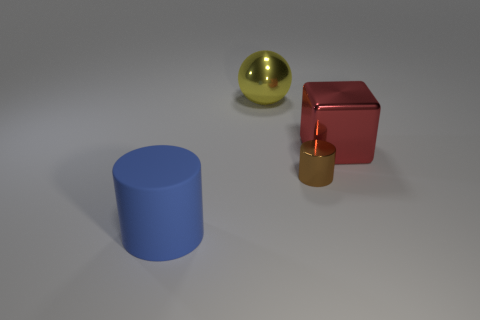Subtract all spheres. How many objects are left? 3 Add 3 large cylinders. How many objects exist? 7 Subtract all big red metallic balls. Subtract all yellow metal things. How many objects are left? 3 Add 3 metal cubes. How many metal cubes are left? 4 Add 2 big yellow things. How many big yellow things exist? 3 Subtract 0 green cylinders. How many objects are left? 4 Subtract all purple cylinders. Subtract all blue spheres. How many cylinders are left? 2 